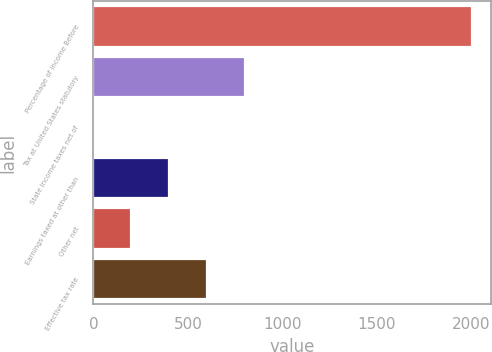<chart> <loc_0><loc_0><loc_500><loc_500><bar_chart><fcel>Percentage of Income Before<fcel>Tax at United States statutory<fcel>State income taxes net of<fcel>Earnings taxed at other than<fcel>Other net<fcel>Effective tax rate<nl><fcel>2003<fcel>801.74<fcel>0.9<fcel>401.32<fcel>201.11<fcel>601.53<nl></chart> 